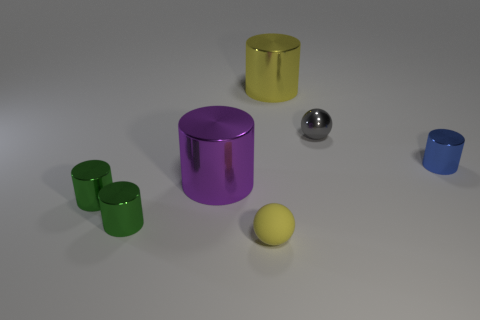What size is the cylinder that is the same color as the small rubber sphere? The large purple cylinder appears to be the one that matches the color of the small rubber sphere. 